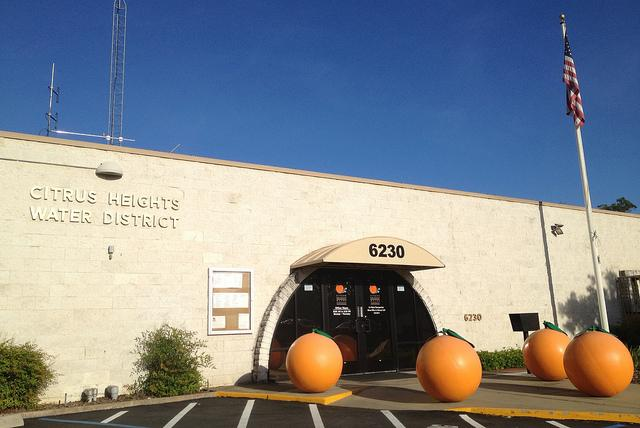What time in the morning does this building open to the public? Please explain your reasoning. eight. The citrus heights water district is open from 8:00am to 5:30pm. 